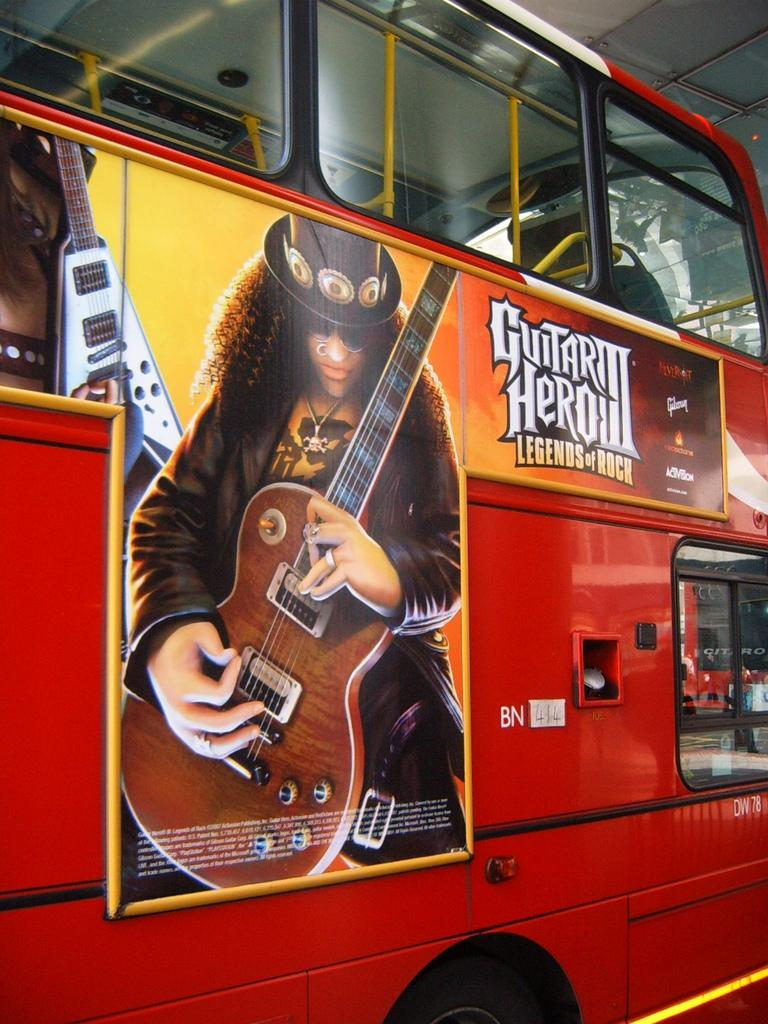What is the main subject of the picture? The main subject of the picture is a bus. What is attached to the bus in the image? A poster is stuck on the bus. What is depicted on the poster? The poster features a man. What is the man wearing on his head? The man is wearing a hat. What is the man holding in his hands? The man is holding a guitar in his hands. Can you tell me how the monkey is swimming in the image? There is no monkey or swimming activity depicted in the image; it features a bus with a poster of a man holding a guitar. 